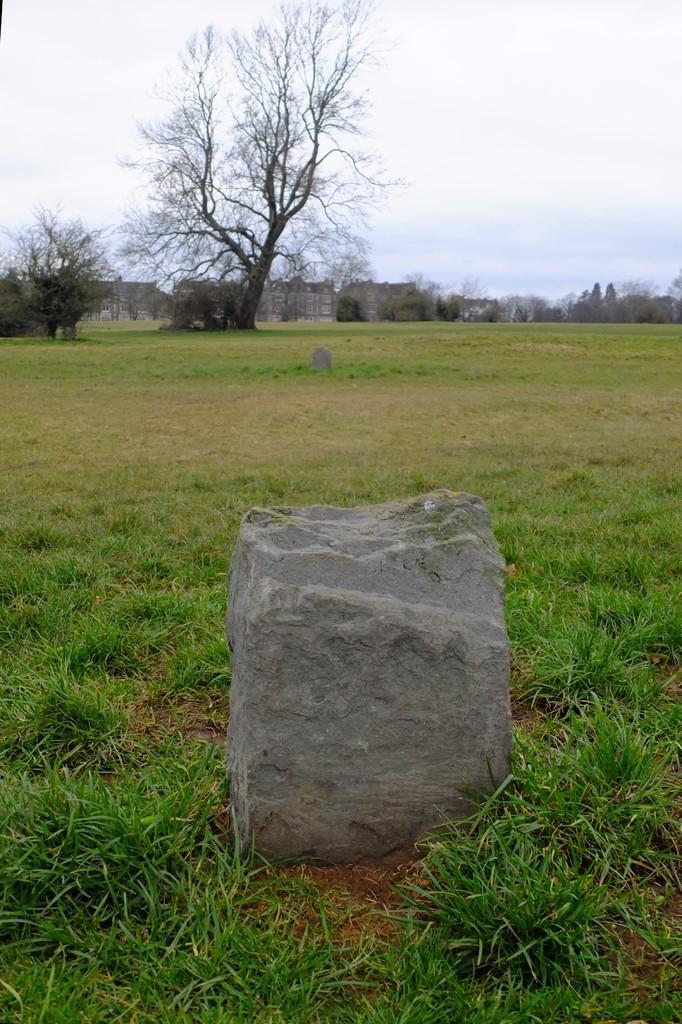Could you give a brief overview of what you see in this image? In the center of the image, we can see a stone and in the background, there are trees and we can see buildings. At the bottom, there is another stone on the ground covered with grass. 